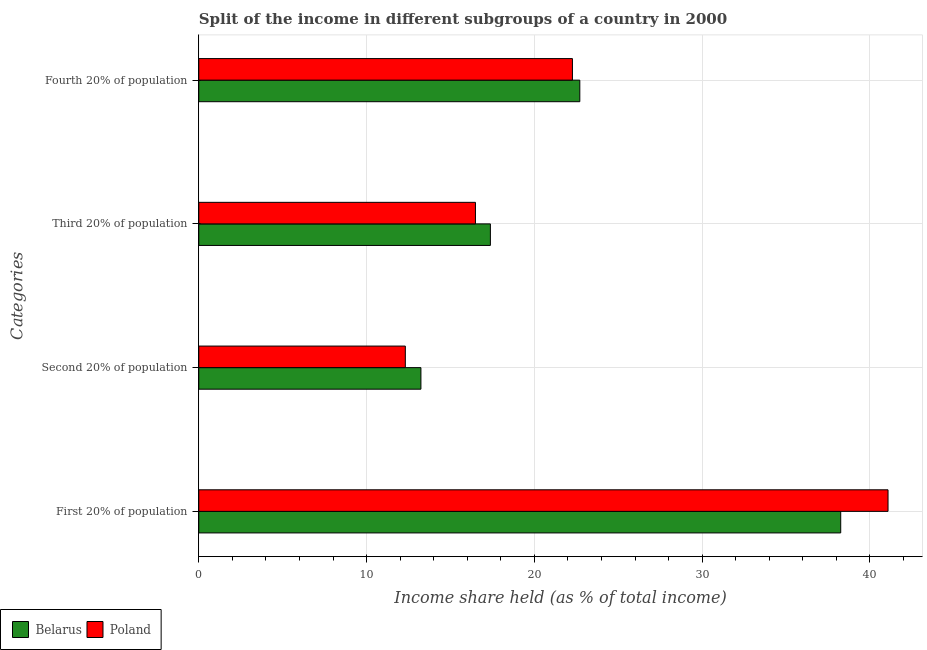Are the number of bars per tick equal to the number of legend labels?
Provide a succinct answer. Yes. Are the number of bars on each tick of the Y-axis equal?
Ensure brevity in your answer.  Yes. How many bars are there on the 3rd tick from the top?
Your answer should be very brief. 2. What is the label of the 4th group of bars from the top?
Offer a terse response. First 20% of population. What is the share of the income held by third 20% of the population in Poland?
Offer a terse response. 16.49. Across all countries, what is the maximum share of the income held by third 20% of the population?
Give a very brief answer. 17.38. Across all countries, what is the minimum share of the income held by first 20% of the population?
Your answer should be very brief. 38.26. What is the total share of the income held by third 20% of the population in the graph?
Ensure brevity in your answer.  33.87. What is the difference between the share of the income held by fourth 20% of the population in Belarus and that in Poland?
Your answer should be compact. 0.44. What is the difference between the share of the income held by third 20% of the population in Poland and the share of the income held by second 20% of the population in Belarus?
Offer a terse response. 3.25. What is the average share of the income held by fourth 20% of the population per country?
Offer a terse response. 22.49. What is the difference between the share of the income held by third 20% of the population and share of the income held by first 20% of the population in Belarus?
Your answer should be very brief. -20.88. What is the ratio of the share of the income held by third 20% of the population in Poland to that in Belarus?
Make the answer very short. 0.95. Is the share of the income held by first 20% of the population in Belarus less than that in Poland?
Ensure brevity in your answer.  Yes. What is the difference between the highest and the second highest share of the income held by fourth 20% of the population?
Offer a very short reply. 0.44. What is the difference between the highest and the lowest share of the income held by fourth 20% of the population?
Provide a short and direct response. 0.44. Is the sum of the share of the income held by fourth 20% of the population in Poland and Belarus greater than the maximum share of the income held by first 20% of the population across all countries?
Provide a short and direct response. Yes. What does the 2nd bar from the top in First 20% of population represents?
Make the answer very short. Belarus. What does the 1st bar from the bottom in Fourth 20% of population represents?
Your answer should be compact. Belarus. Are all the bars in the graph horizontal?
Provide a succinct answer. Yes. Are the values on the major ticks of X-axis written in scientific E-notation?
Your answer should be very brief. No. Does the graph contain any zero values?
Provide a short and direct response. No. Where does the legend appear in the graph?
Your response must be concise. Bottom left. What is the title of the graph?
Provide a short and direct response. Split of the income in different subgroups of a country in 2000. What is the label or title of the X-axis?
Provide a short and direct response. Income share held (as % of total income). What is the label or title of the Y-axis?
Ensure brevity in your answer.  Categories. What is the Income share held (as % of total income) in Belarus in First 20% of population?
Offer a very short reply. 38.26. What is the Income share held (as % of total income) in Poland in First 20% of population?
Your response must be concise. 41.08. What is the Income share held (as % of total income) of Belarus in Second 20% of population?
Provide a succinct answer. 13.24. What is the Income share held (as % of total income) of Poland in Second 20% of population?
Provide a succinct answer. 12.31. What is the Income share held (as % of total income) of Belarus in Third 20% of population?
Keep it short and to the point. 17.38. What is the Income share held (as % of total income) of Poland in Third 20% of population?
Your answer should be very brief. 16.49. What is the Income share held (as % of total income) of Belarus in Fourth 20% of population?
Keep it short and to the point. 22.71. What is the Income share held (as % of total income) in Poland in Fourth 20% of population?
Your answer should be very brief. 22.27. Across all Categories, what is the maximum Income share held (as % of total income) in Belarus?
Your response must be concise. 38.26. Across all Categories, what is the maximum Income share held (as % of total income) in Poland?
Give a very brief answer. 41.08. Across all Categories, what is the minimum Income share held (as % of total income) of Belarus?
Your response must be concise. 13.24. Across all Categories, what is the minimum Income share held (as % of total income) in Poland?
Your answer should be compact. 12.31. What is the total Income share held (as % of total income) in Belarus in the graph?
Ensure brevity in your answer.  91.59. What is the total Income share held (as % of total income) of Poland in the graph?
Your response must be concise. 92.15. What is the difference between the Income share held (as % of total income) of Belarus in First 20% of population and that in Second 20% of population?
Ensure brevity in your answer.  25.02. What is the difference between the Income share held (as % of total income) of Poland in First 20% of population and that in Second 20% of population?
Your answer should be compact. 28.77. What is the difference between the Income share held (as % of total income) in Belarus in First 20% of population and that in Third 20% of population?
Offer a terse response. 20.88. What is the difference between the Income share held (as % of total income) in Poland in First 20% of population and that in Third 20% of population?
Offer a very short reply. 24.59. What is the difference between the Income share held (as % of total income) in Belarus in First 20% of population and that in Fourth 20% of population?
Give a very brief answer. 15.55. What is the difference between the Income share held (as % of total income) in Poland in First 20% of population and that in Fourth 20% of population?
Keep it short and to the point. 18.81. What is the difference between the Income share held (as % of total income) of Belarus in Second 20% of population and that in Third 20% of population?
Your answer should be very brief. -4.14. What is the difference between the Income share held (as % of total income) of Poland in Second 20% of population and that in Third 20% of population?
Your answer should be very brief. -4.18. What is the difference between the Income share held (as % of total income) in Belarus in Second 20% of population and that in Fourth 20% of population?
Keep it short and to the point. -9.47. What is the difference between the Income share held (as % of total income) in Poland in Second 20% of population and that in Fourth 20% of population?
Provide a short and direct response. -9.96. What is the difference between the Income share held (as % of total income) in Belarus in Third 20% of population and that in Fourth 20% of population?
Offer a very short reply. -5.33. What is the difference between the Income share held (as % of total income) of Poland in Third 20% of population and that in Fourth 20% of population?
Offer a very short reply. -5.78. What is the difference between the Income share held (as % of total income) of Belarus in First 20% of population and the Income share held (as % of total income) of Poland in Second 20% of population?
Offer a very short reply. 25.95. What is the difference between the Income share held (as % of total income) in Belarus in First 20% of population and the Income share held (as % of total income) in Poland in Third 20% of population?
Ensure brevity in your answer.  21.77. What is the difference between the Income share held (as % of total income) in Belarus in First 20% of population and the Income share held (as % of total income) in Poland in Fourth 20% of population?
Your response must be concise. 15.99. What is the difference between the Income share held (as % of total income) in Belarus in Second 20% of population and the Income share held (as % of total income) in Poland in Third 20% of population?
Your answer should be very brief. -3.25. What is the difference between the Income share held (as % of total income) of Belarus in Second 20% of population and the Income share held (as % of total income) of Poland in Fourth 20% of population?
Your answer should be very brief. -9.03. What is the difference between the Income share held (as % of total income) in Belarus in Third 20% of population and the Income share held (as % of total income) in Poland in Fourth 20% of population?
Your answer should be very brief. -4.89. What is the average Income share held (as % of total income) of Belarus per Categories?
Give a very brief answer. 22.9. What is the average Income share held (as % of total income) in Poland per Categories?
Your answer should be very brief. 23.04. What is the difference between the Income share held (as % of total income) of Belarus and Income share held (as % of total income) of Poland in First 20% of population?
Offer a very short reply. -2.82. What is the difference between the Income share held (as % of total income) of Belarus and Income share held (as % of total income) of Poland in Second 20% of population?
Offer a very short reply. 0.93. What is the difference between the Income share held (as % of total income) in Belarus and Income share held (as % of total income) in Poland in Third 20% of population?
Make the answer very short. 0.89. What is the difference between the Income share held (as % of total income) of Belarus and Income share held (as % of total income) of Poland in Fourth 20% of population?
Make the answer very short. 0.44. What is the ratio of the Income share held (as % of total income) of Belarus in First 20% of population to that in Second 20% of population?
Offer a very short reply. 2.89. What is the ratio of the Income share held (as % of total income) of Poland in First 20% of population to that in Second 20% of population?
Provide a succinct answer. 3.34. What is the ratio of the Income share held (as % of total income) in Belarus in First 20% of population to that in Third 20% of population?
Offer a terse response. 2.2. What is the ratio of the Income share held (as % of total income) of Poland in First 20% of population to that in Third 20% of population?
Make the answer very short. 2.49. What is the ratio of the Income share held (as % of total income) in Belarus in First 20% of population to that in Fourth 20% of population?
Offer a very short reply. 1.68. What is the ratio of the Income share held (as % of total income) of Poland in First 20% of population to that in Fourth 20% of population?
Your response must be concise. 1.84. What is the ratio of the Income share held (as % of total income) in Belarus in Second 20% of population to that in Third 20% of population?
Provide a succinct answer. 0.76. What is the ratio of the Income share held (as % of total income) in Poland in Second 20% of population to that in Third 20% of population?
Provide a succinct answer. 0.75. What is the ratio of the Income share held (as % of total income) of Belarus in Second 20% of population to that in Fourth 20% of population?
Provide a short and direct response. 0.58. What is the ratio of the Income share held (as % of total income) of Poland in Second 20% of population to that in Fourth 20% of population?
Make the answer very short. 0.55. What is the ratio of the Income share held (as % of total income) of Belarus in Third 20% of population to that in Fourth 20% of population?
Your response must be concise. 0.77. What is the ratio of the Income share held (as % of total income) of Poland in Third 20% of population to that in Fourth 20% of population?
Provide a succinct answer. 0.74. What is the difference between the highest and the second highest Income share held (as % of total income) of Belarus?
Offer a terse response. 15.55. What is the difference between the highest and the second highest Income share held (as % of total income) of Poland?
Your response must be concise. 18.81. What is the difference between the highest and the lowest Income share held (as % of total income) of Belarus?
Ensure brevity in your answer.  25.02. What is the difference between the highest and the lowest Income share held (as % of total income) of Poland?
Your response must be concise. 28.77. 